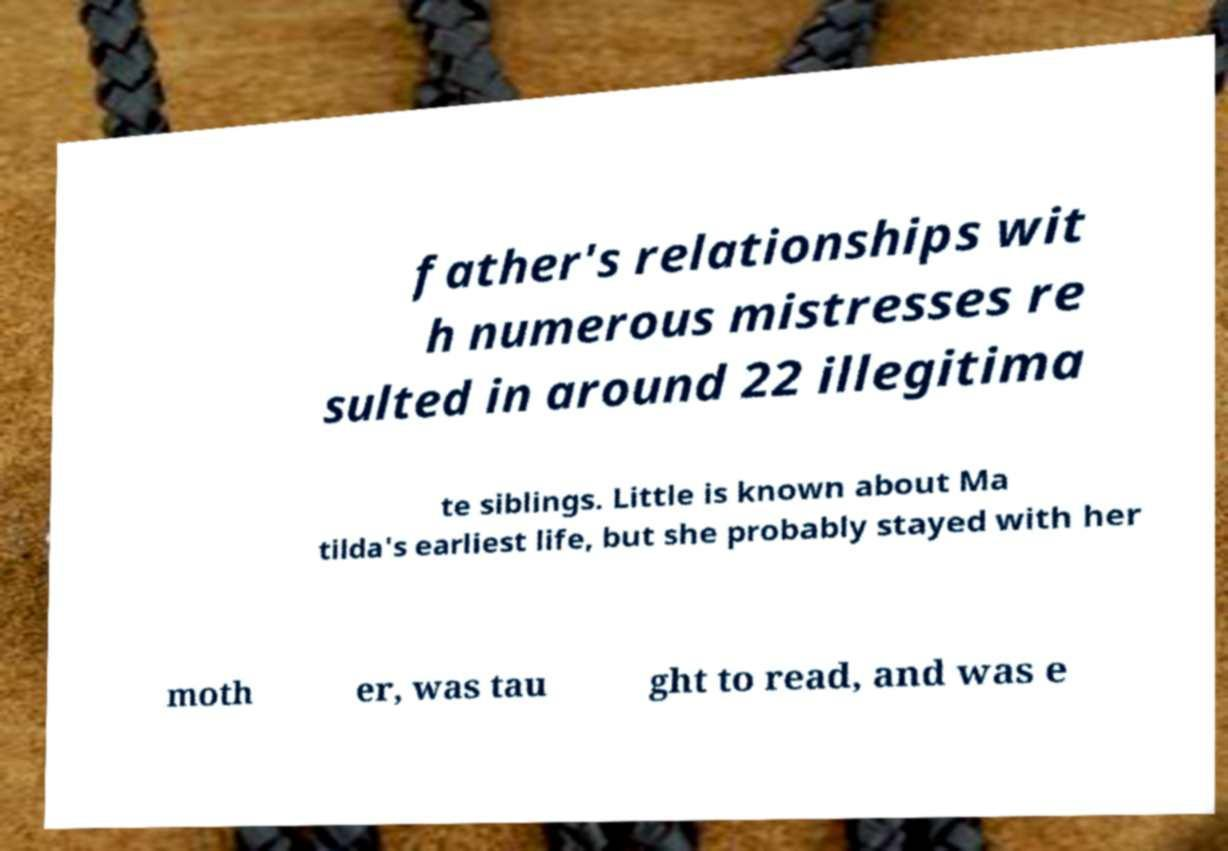Can you accurately transcribe the text from the provided image for me? father's relationships wit h numerous mistresses re sulted in around 22 illegitima te siblings. Little is known about Ma tilda's earliest life, but she probably stayed with her moth er, was tau ght to read, and was e 